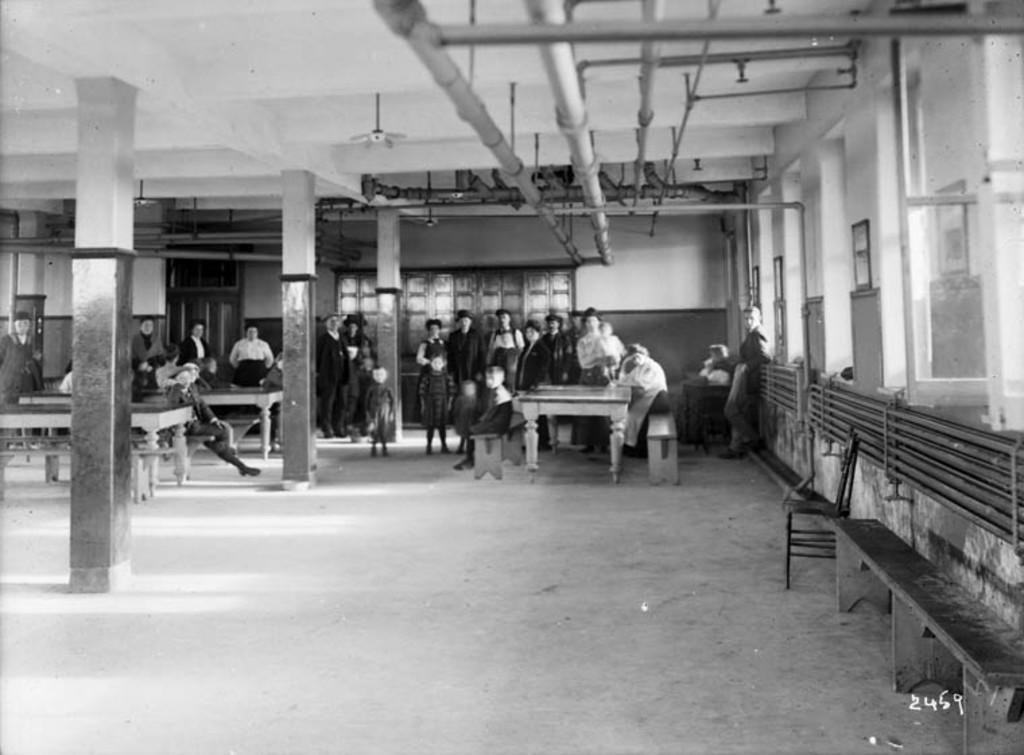In one or two sentences, can you explain what this image depicts? In this picture I can observe some people standing on the floor. There are some children in this picture along with men and women. This is a black and white image. 